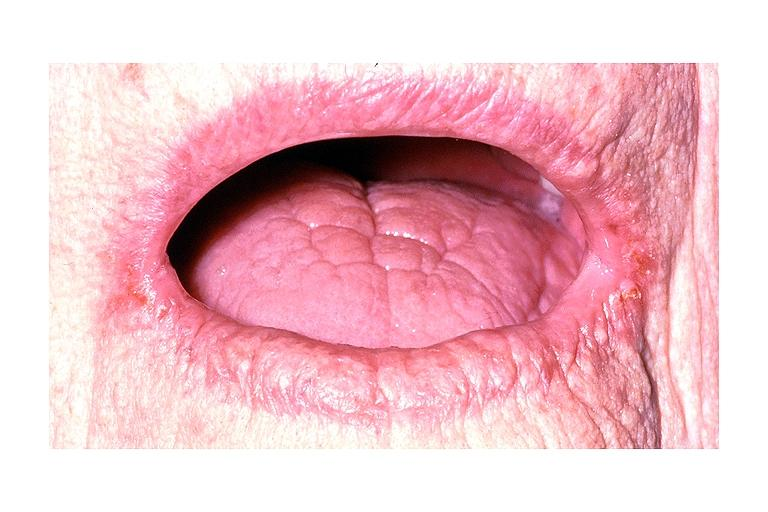what does this image show?
Answer the question using a single word or phrase. Angular chelitis 